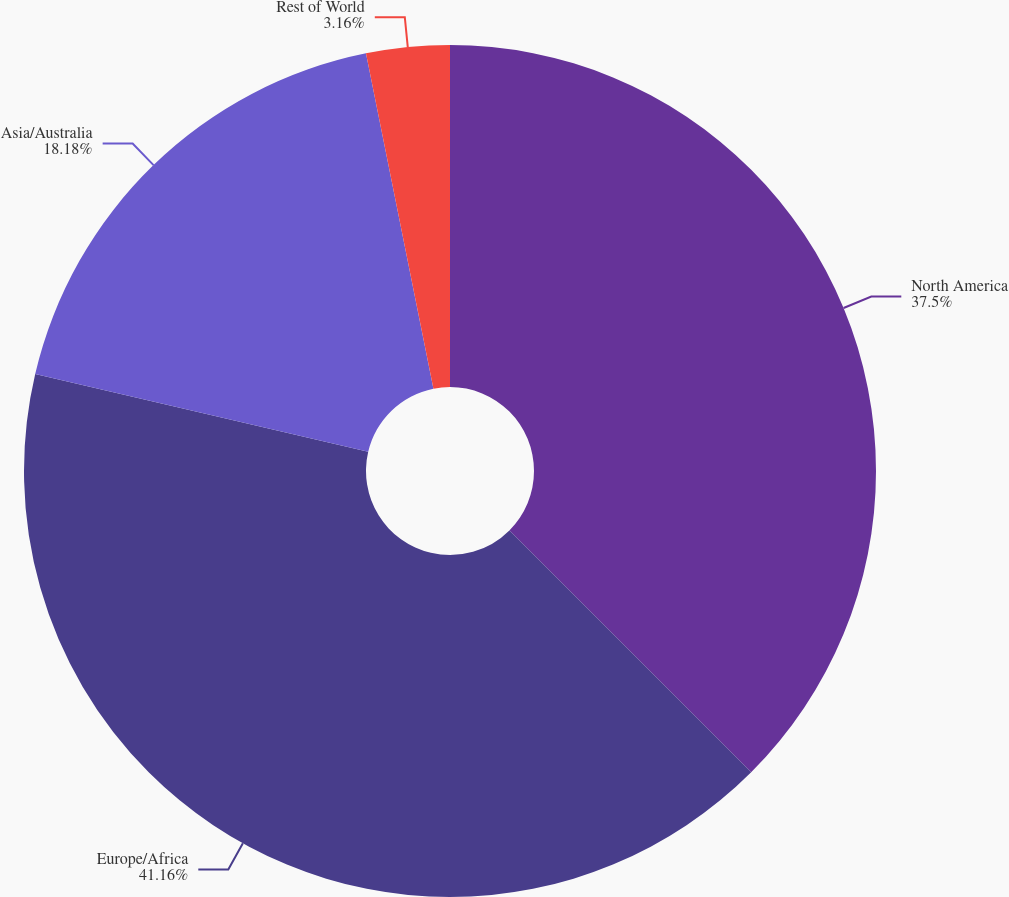Convert chart. <chart><loc_0><loc_0><loc_500><loc_500><pie_chart><fcel>North America<fcel>Europe/Africa<fcel>Asia/Australia<fcel>Rest of World<nl><fcel>37.5%<fcel>41.15%<fcel>18.18%<fcel>3.16%<nl></chart> 